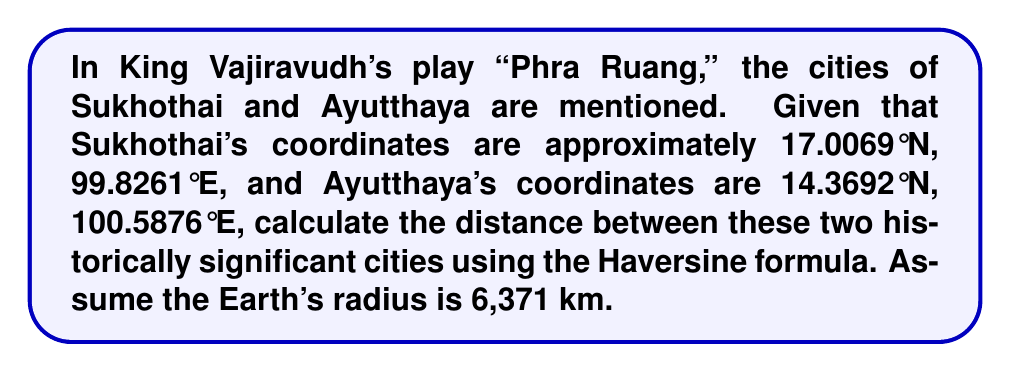Can you answer this question? To calculate the distance between Sukhothai and Ayutthaya using their latitude and longitude coordinates, we'll use the Haversine formula:

1) Convert the latitudes and longitudes from degrees to radians:
   $$\phi_1 = 17.0069° \times \frac{\pi}{180} = 0.2968 \text{ rad}$$
   $$\lambda_1 = 99.8261° \times \frac{\pi}{180} = 1.7426 \text{ rad}$$
   $$\phi_2 = 14.3692° \times \frac{\pi}{180} = 0.2508 \text{ rad}$$
   $$\lambda_2 = 100.5876° \times \frac{\pi}{180} = 1.7557 \text{ rad}$$

2) Calculate the differences:
   $$\Delta\phi = \phi_2 - \phi_1 = 0.2508 - 0.2968 = -0.0460 \text{ rad}$$
   $$\Delta\lambda = \lambda_2 - \lambda_1 = 1.7557 - 1.7426 = 0.0131 \text{ rad}$$

3) Apply the Haversine formula:
   $$a = \sin^2(\frac{\Delta\phi}{2}) + \cos(\phi_1) \cos(\phi_2) \sin^2(\frac{\Delta\lambda}{2})$$
   $$a = \sin^2(-0.0230) + \cos(0.2968) \cos(0.2508) \sin^2(0.00655)$$
   $$a = 0.000529 + 0.955 \times 0.969 \times 0.00000429 = 0.000533$$

4) Calculate the central angle:
   $$c = 2 \times \arctan2(\sqrt{a}, \sqrt{1-a})$$
   $$c = 2 \times \arctan2(\sqrt{0.000533}, \sqrt{1-0.000533}) = 0.0461 \text{ rad}$$

5) Calculate the distance:
   $$d = R \times c = 6371 \times 0.0461 = 293.6 \text{ km}$$

Therefore, the distance between Sukhothai and Ayutthaya is approximately 293.6 km.
Answer: 293.6 km 